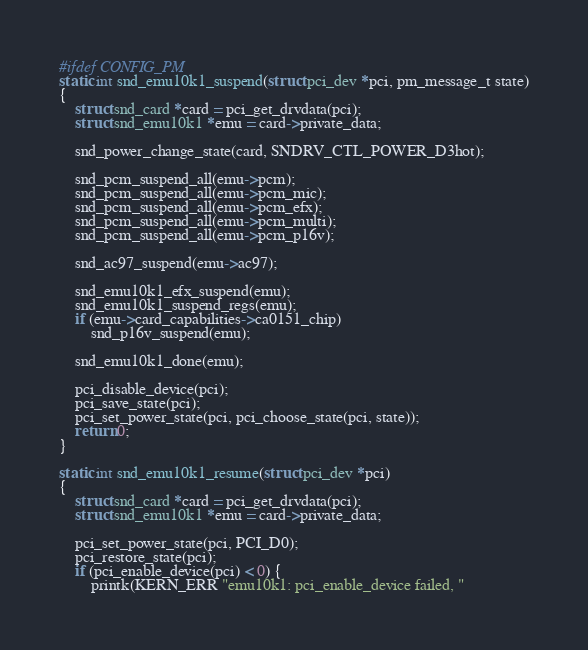Convert code to text. <code><loc_0><loc_0><loc_500><loc_500><_C_>
#ifdef CONFIG_PM
static int snd_emu10k1_suspend(struct pci_dev *pci, pm_message_t state)
{
	struct snd_card *card = pci_get_drvdata(pci);
	struct snd_emu10k1 *emu = card->private_data;

	snd_power_change_state(card, SNDRV_CTL_POWER_D3hot);

	snd_pcm_suspend_all(emu->pcm);
	snd_pcm_suspend_all(emu->pcm_mic);
	snd_pcm_suspend_all(emu->pcm_efx);
	snd_pcm_suspend_all(emu->pcm_multi);
	snd_pcm_suspend_all(emu->pcm_p16v);

	snd_ac97_suspend(emu->ac97);

	snd_emu10k1_efx_suspend(emu);
	snd_emu10k1_suspend_regs(emu);
	if (emu->card_capabilities->ca0151_chip)
		snd_p16v_suspend(emu);

	snd_emu10k1_done(emu);

	pci_disable_device(pci);
	pci_save_state(pci);
	pci_set_power_state(pci, pci_choose_state(pci, state));
	return 0;
}

static int snd_emu10k1_resume(struct pci_dev *pci)
{
	struct snd_card *card = pci_get_drvdata(pci);
	struct snd_emu10k1 *emu = card->private_data;

	pci_set_power_state(pci, PCI_D0);
	pci_restore_state(pci);
	if (pci_enable_device(pci) < 0) {
		printk(KERN_ERR "emu10k1: pci_enable_device failed, "</code> 